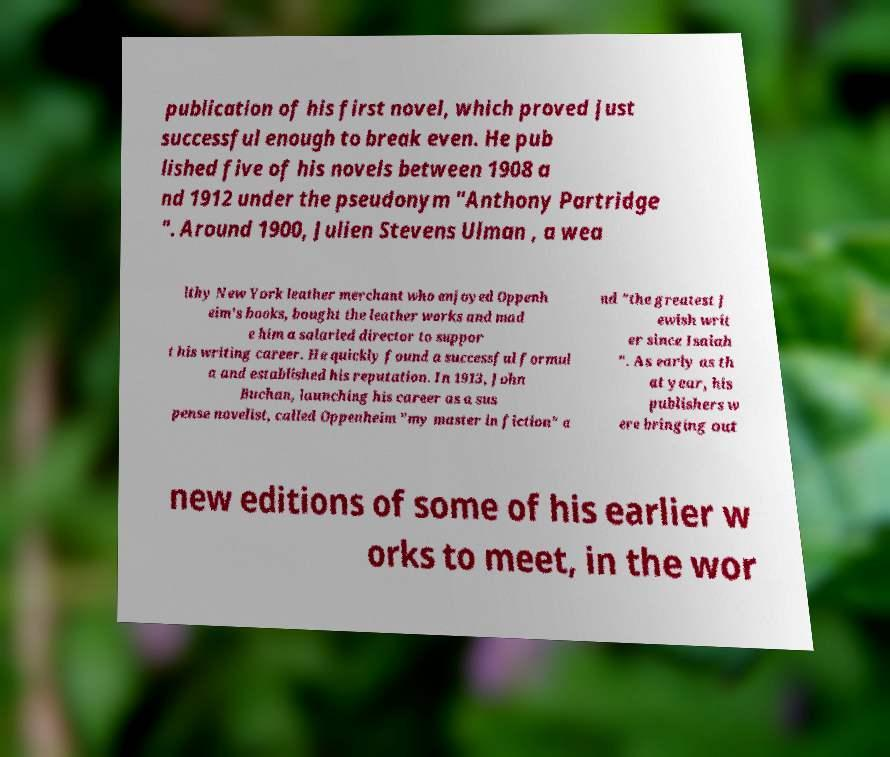Could you extract and type out the text from this image? publication of his first novel, which proved just successful enough to break even. He pub lished five of his novels between 1908 a nd 1912 under the pseudonym "Anthony Partridge ". Around 1900, Julien Stevens Ulman , a wea lthy New York leather merchant who enjoyed Oppenh eim's books, bought the leather works and mad e him a salaried director to suppor t his writing career. He quickly found a successful formul a and established his reputation. In 1913, John Buchan, launching his career as a sus pense novelist, called Oppenheim "my master in fiction" a nd "the greatest J ewish writ er since Isaiah ". As early as th at year, his publishers w ere bringing out new editions of some of his earlier w orks to meet, in the wor 